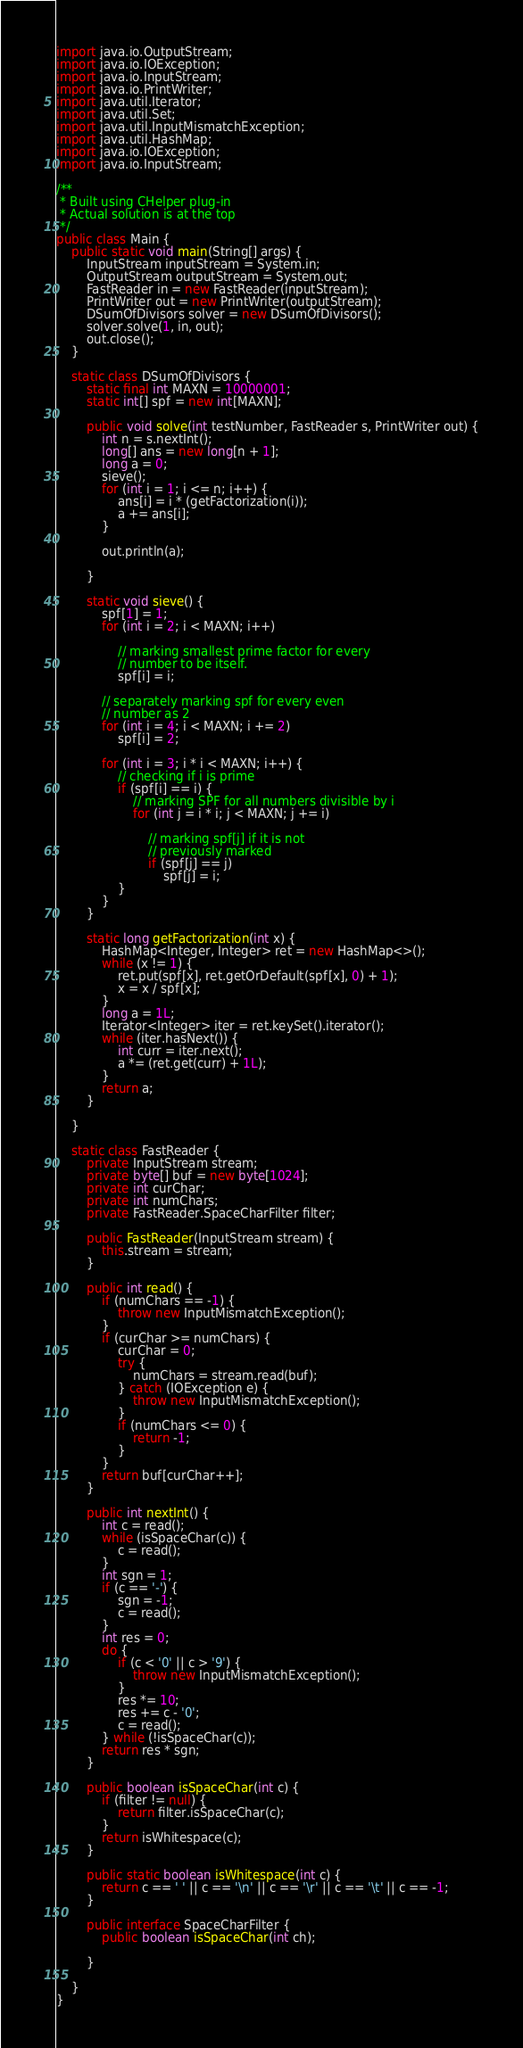Convert code to text. <code><loc_0><loc_0><loc_500><loc_500><_Java_>import java.io.OutputStream;
import java.io.IOException;
import java.io.InputStream;
import java.io.PrintWriter;
import java.util.Iterator;
import java.util.Set;
import java.util.InputMismatchException;
import java.util.HashMap;
import java.io.IOException;
import java.io.InputStream;

/**
 * Built using CHelper plug-in
 * Actual solution is at the top
 */
public class Main {
    public static void main(String[] args) {
        InputStream inputStream = System.in;
        OutputStream outputStream = System.out;
        FastReader in = new FastReader(inputStream);
        PrintWriter out = new PrintWriter(outputStream);
        DSumOfDivisors solver = new DSumOfDivisors();
        solver.solve(1, in, out);
        out.close();
    }

    static class DSumOfDivisors {
        static final int MAXN = 10000001;
        static int[] spf = new int[MAXN];

        public void solve(int testNumber, FastReader s, PrintWriter out) {
            int n = s.nextInt();
            long[] ans = new long[n + 1];
            long a = 0;
            sieve();
            for (int i = 1; i <= n; i++) {
                ans[i] = i * (getFactorization(i));
                a += ans[i];
            }

            out.println(a);

        }

        static void sieve() {
            spf[1] = 1;
            for (int i = 2; i < MAXN; i++)

                // marking smallest prime factor for every
                // number to be itself.
                spf[i] = i;

            // separately marking spf for every even
            // number as 2
            for (int i = 4; i < MAXN; i += 2)
                spf[i] = 2;

            for (int i = 3; i * i < MAXN; i++) {
                // checking if i is prime
                if (spf[i] == i) {
                    // marking SPF for all numbers divisible by i
                    for (int j = i * i; j < MAXN; j += i)

                        // marking spf[j] if it is not
                        // previously marked
                        if (spf[j] == j)
                            spf[j] = i;
                }
            }
        }

        static long getFactorization(int x) {
            HashMap<Integer, Integer> ret = new HashMap<>();
            while (x != 1) {
                ret.put(spf[x], ret.getOrDefault(spf[x], 0) + 1);
                x = x / spf[x];
            }
            long a = 1L;
            Iterator<Integer> iter = ret.keySet().iterator();
            while (iter.hasNext()) {
                int curr = iter.next();
                a *= (ret.get(curr) + 1L);
            }
            return a;
        }

    }

    static class FastReader {
        private InputStream stream;
        private byte[] buf = new byte[1024];
        private int curChar;
        private int numChars;
        private FastReader.SpaceCharFilter filter;

        public FastReader(InputStream stream) {
            this.stream = stream;
        }

        public int read() {
            if (numChars == -1) {
                throw new InputMismatchException();
            }
            if (curChar >= numChars) {
                curChar = 0;
                try {
                    numChars = stream.read(buf);
                } catch (IOException e) {
                    throw new InputMismatchException();
                }
                if (numChars <= 0) {
                    return -1;
                }
            }
            return buf[curChar++];
        }

        public int nextInt() {
            int c = read();
            while (isSpaceChar(c)) {
                c = read();
            }
            int sgn = 1;
            if (c == '-') {
                sgn = -1;
                c = read();
            }
            int res = 0;
            do {
                if (c < '0' || c > '9') {
                    throw new InputMismatchException();
                }
                res *= 10;
                res += c - '0';
                c = read();
            } while (!isSpaceChar(c));
            return res * sgn;
        }

        public boolean isSpaceChar(int c) {
            if (filter != null) {
                return filter.isSpaceChar(c);
            }
            return isWhitespace(c);
        }

        public static boolean isWhitespace(int c) {
            return c == ' ' || c == '\n' || c == '\r' || c == '\t' || c == -1;
        }

        public interface SpaceCharFilter {
            public boolean isSpaceChar(int ch);

        }

    }
}

</code> 